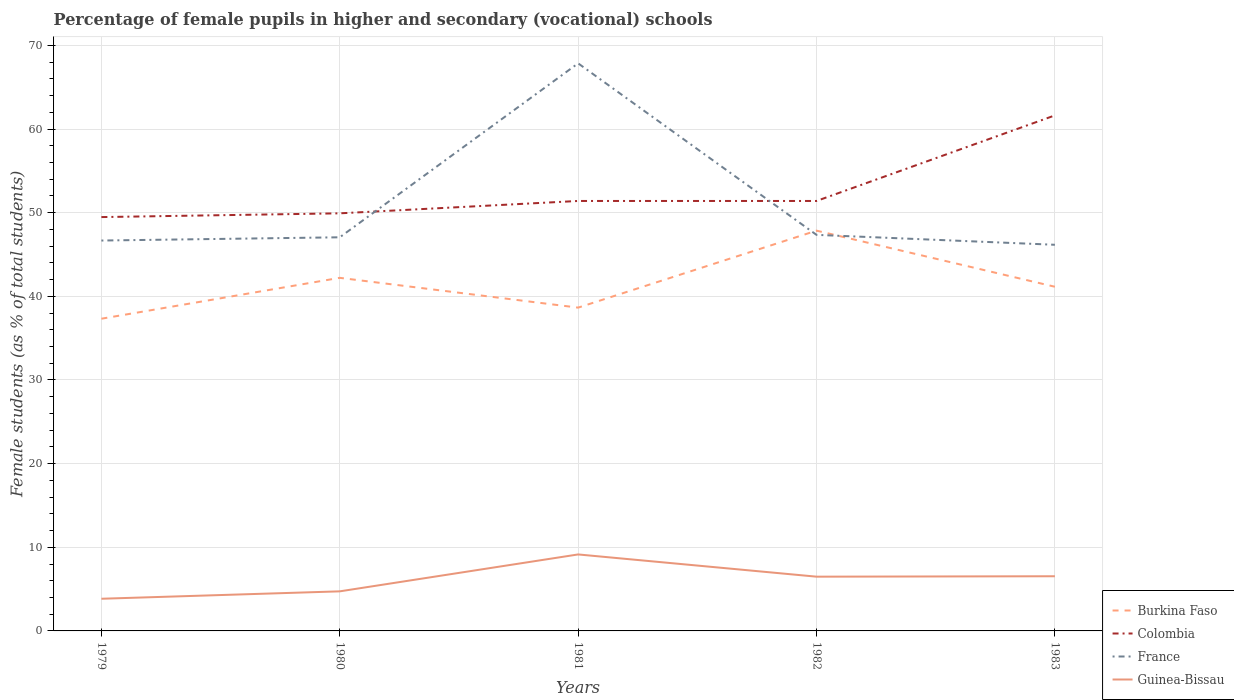Does the line corresponding to France intersect with the line corresponding to Burkina Faso?
Make the answer very short. Yes. Across all years, what is the maximum percentage of female pupils in higher and secondary schools in Guinea-Bissau?
Give a very brief answer. 3.85. In which year was the percentage of female pupils in higher and secondary schools in Colombia maximum?
Your response must be concise. 1979. What is the total percentage of female pupils in higher and secondary schools in Burkina Faso in the graph?
Offer a terse response. -2.5. What is the difference between the highest and the second highest percentage of female pupils in higher and secondary schools in Colombia?
Offer a very short reply. 12.16. What is the difference between the highest and the lowest percentage of female pupils in higher and secondary schools in Colombia?
Your answer should be very brief. 1. Is the percentage of female pupils in higher and secondary schools in Guinea-Bissau strictly greater than the percentage of female pupils in higher and secondary schools in Colombia over the years?
Provide a short and direct response. Yes. How many years are there in the graph?
Provide a succinct answer. 5. What is the difference between two consecutive major ticks on the Y-axis?
Provide a short and direct response. 10. Does the graph contain any zero values?
Provide a succinct answer. No. Does the graph contain grids?
Offer a very short reply. Yes. Where does the legend appear in the graph?
Provide a short and direct response. Bottom right. How many legend labels are there?
Keep it short and to the point. 4. What is the title of the graph?
Offer a very short reply. Percentage of female pupils in higher and secondary (vocational) schools. Does "Cuba" appear as one of the legend labels in the graph?
Offer a terse response. No. What is the label or title of the X-axis?
Ensure brevity in your answer.  Years. What is the label or title of the Y-axis?
Give a very brief answer. Female students (as % of total students). What is the Female students (as % of total students) in Burkina Faso in 1979?
Ensure brevity in your answer.  37.32. What is the Female students (as % of total students) in Colombia in 1979?
Keep it short and to the point. 49.48. What is the Female students (as % of total students) of France in 1979?
Your answer should be very brief. 46.67. What is the Female students (as % of total students) in Guinea-Bissau in 1979?
Make the answer very short. 3.85. What is the Female students (as % of total students) in Burkina Faso in 1980?
Keep it short and to the point. 42.21. What is the Female students (as % of total students) in Colombia in 1980?
Offer a terse response. 49.92. What is the Female students (as % of total students) of France in 1980?
Provide a succinct answer. 47.06. What is the Female students (as % of total students) of Guinea-Bissau in 1980?
Provide a succinct answer. 4.73. What is the Female students (as % of total students) of Burkina Faso in 1981?
Make the answer very short. 38.65. What is the Female students (as % of total students) of Colombia in 1981?
Keep it short and to the point. 51.4. What is the Female students (as % of total students) of France in 1981?
Offer a very short reply. 67.85. What is the Female students (as % of total students) of Guinea-Bissau in 1981?
Provide a succinct answer. 9.14. What is the Female students (as % of total students) in Burkina Faso in 1982?
Your response must be concise. 47.85. What is the Female students (as % of total students) of Colombia in 1982?
Make the answer very short. 51.4. What is the Female students (as % of total students) in France in 1982?
Keep it short and to the point. 47.35. What is the Female students (as % of total students) in Guinea-Bissau in 1982?
Your response must be concise. 6.49. What is the Female students (as % of total students) of Burkina Faso in 1983?
Give a very brief answer. 41.15. What is the Female students (as % of total students) of Colombia in 1983?
Your answer should be compact. 61.63. What is the Female students (as % of total students) of France in 1983?
Offer a terse response. 46.16. What is the Female students (as % of total students) of Guinea-Bissau in 1983?
Give a very brief answer. 6.54. Across all years, what is the maximum Female students (as % of total students) in Burkina Faso?
Ensure brevity in your answer.  47.85. Across all years, what is the maximum Female students (as % of total students) of Colombia?
Offer a very short reply. 61.63. Across all years, what is the maximum Female students (as % of total students) of France?
Your response must be concise. 67.85. Across all years, what is the maximum Female students (as % of total students) in Guinea-Bissau?
Your response must be concise. 9.14. Across all years, what is the minimum Female students (as % of total students) in Burkina Faso?
Provide a succinct answer. 37.32. Across all years, what is the minimum Female students (as % of total students) in Colombia?
Your response must be concise. 49.48. Across all years, what is the minimum Female students (as % of total students) in France?
Your answer should be compact. 46.16. Across all years, what is the minimum Female students (as % of total students) in Guinea-Bissau?
Your response must be concise. 3.85. What is the total Female students (as % of total students) in Burkina Faso in the graph?
Offer a terse response. 207.19. What is the total Female students (as % of total students) in Colombia in the graph?
Provide a succinct answer. 263.83. What is the total Female students (as % of total students) of France in the graph?
Your answer should be compact. 255.1. What is the total Female students (as % of total students) of Guinea-Bissau in the graph?
Ensure brevity in your answer.  30.74. What is the difference between the Female students (as % of total students) of Burkina Faso in 1979 and that in 1980?
Provide a short and direct response. -4.89. What is the difference between the Female students (as % of total students) in Colombia in 1979 and that in 1980?
Make the answer very short. -0.45. What is the difference between the Female students (as % of total students) in France in 1979 and that in 1980?
Keep it short and to the point. -0.39. What is the difference between the Female students (as % of total students) in Guinea-Bissau in 1979 and that in 1980?
Provide a short and direct response. -0.89. What is the difference between the Female students (as % of total students) of Burkina Faso in 1979 and that in 1981?
Make the answer very short. -1.33. What is the difference between the Female students (as % of total students) of Colombia in 1979 and that in 1981?
Offer a very short reply. -1.93. What is the difference between the Female students (as % of total students) in France in 1979 and that in 1981?
Offer a terse response. -21.18. What is the difference between the Female students (as % of total students) of Guinea-Bissau in 1979 and that in 1981?
Provide a short and direct response. -5.3. What is the difference between the Female students (as % of total students) in Burkina Faso in 1979 and that in 1982?
Provide a short and direct response. -10.53. What is the difference between the Female students (as % of total students) in Colombia in 1979 and that in 1982?
Make the answer very short. -1.93. What is the difference between the Female students (as % of total students) of France in 1979 and that in 1982?
Your answer should be compact. -0.68. What is the difference between the Female students (as % of total students) in Guinea-Bissau in 1979 and that in 1982?
Your response must be concise. -2.64. What is the difference between the Female students (as % of total students) in Burkina Faso in 1979 and that in 1983?
Give a very brief answer. -3.82. What is the difference between the Female students (as % of total students) of Colombia in 1979 and that in 1983?
Keep it short and to the point. -12.16. What is the difference between the Female students (as % of total students) in France in 1979 and that in 1983?
Your answer should be compact. 0.51. What is the difference between the Female students (as % of total students) in Guinea-Bissau in 1979 and that in 1983?
Offer a very short reply. -2.69. What is the difference between the Female students (as % of total students) of Burkina Faso in 1980 and that in 1981?
Make the answer very short. 3.56. What is the difference between the Female students (as % of total students) in Colombia in 1980 and that in 1981?
Your answer should be very brief. -1.48. What is the difference between the Female students (as % of total students) in France in 1980 and that in 1981?
Your answer should be very brief. -20.8. What is the difference between the Female students (as % of total students) of Guinea-Bissau in 1980 and that in 1981?
Ensure brevity in your answer.  -4.41. What is the difference between the Female students (as % of total students) in Burkina Faso in 1980 and that in 1982?
Ensure brevity in your answer.  -5.64. What is the difference between the Female students (as % of total students) in Colombia in 1980 and that in 1982?
Give a very brief answer. -1.48. What is the difference between the Female students (as % of total students) in France in 1980 and that in 1982?
Provide a short and direct response. -0.29. What is the difference between the Female students (as % of total students) of Guinea-Bissau in 1980 and that in 1982?
Keep it short and to the point. -1.75. What is the difference between the Female students (as % of total students) in Burkina Faso in 1980 and that in 1983?
Make the answer very short. 1.07. What is the difference between the Female students (as % of total students) in Colombia in 1980 and that in 1983?
Your response must be concise. -11.71. What is the difference between the Female students (as % of total students) of France in 1980 and that in 1983?
Your response must be concise. 0.9. What is the difference between the Female students (as % of total students) of Guinea-Bissau in 1980 and that in 1983?
Your answer should be very brief. -1.8. What is the difference between the Female students (as % of total students) of Burkina Faso in 1981 and that in 1982?
Offer a terse response. -9.2. What is the difference between the Female students (as % of total students) in Colombia in 1981 and that in 1982?
Offer a very short reply. 0. What is the difference between the Female students (as % of total students) of France in 1981 and that in 1982?
Keep it short and to the point. 20.5. What is the difference between the Female students (as % of total students) of Guinea-Bissau in 1981 and that in 1982?
Make the answer very short. 2.66. What is the difference between the Female students (as % of total students) in Burkina Faso in 1981 and that in 1983?
Your answer should be very brief. -2.5. What is the difference between the Female students (as % of total students) in Colombia in 1981 and that in 1983?
Offer a very short reply. -10.23. What is the difference between the Female students (as % of total students) in France in 1981 and that in 1983?
Offer a very short reply. 21.69. What is the difference between the Female students (as % of total students) in Guinea-Bissau in 1981 and that in 1983?
Provide a succinct answer. 2.61. What is the difference between the Female students (as % of total students) in Burkina Faso in 1982 and that in 1983?
Give a very brief answer. 6.71. What is the difference between the Female students (as % of total students) of Colombia in 1982 and that in 1983?
Provide a succinct answer. -10.23. What is the difference between the Female students (as % of total students) in France in 1982 and that in 1983?
Make the answer very short. 1.19. What is the difference between the Female students (as % of total students) of Guinea-Bissau in 1982 and that in 1983?
Offer a very short reply. -0.05. What is the difference between the Female students (as % of total students) in Burkina Faso in 1979 and the Female students (as % of total students) in Colombia in 1980?
Offer a terse response. -12.6. What is the difference between the Female students (as % of total students) in Burkina Faso in 1979 and the Female students (as % of total students) in France in 1980?
Your response must be concise. -9.74. What is the difference between the Female students (as % of total students) of Burkina Faso in 1979 and the Female students (as % of total students) of Guinea-Bissau in 1980?
Your answer should be compact. 32.59. What is the difference between the Female students (as % of total students) of Colombia in 1979 and the Female students (as % of total students) of France in 1980?
Offer a terse response. 2.42. What is the difference between the Female students (as % of total students) in Colombia in 1979 and the Female students (as % of total students) in Guinea-Bissau in 1980?
Provide a succinct answer. 44.74. What is the difference between the Female students (as % of total students) of France in 1979 and the Female students (as % of total students) of Guinea-Bissau in 1980?
Your response must be concise. 41.94. What is the difference between the Female students (as % of total students) of Burkina Faso in 1979 and the Female students (as % of total students) of Colombia in 1981?
Keep it short and to the point. -14.08. What is the difference between the Female students (as % of total students) in Burkina Faso in 1979 and the Female students (as % of total students) in France in 1981?
Offer a very short reply. -30.53. What is the difference between the Female students (as % of total students) of Burkina Faso in 1979 and the Female students (as % of total students) of Guinea-Bissau in 1981?
Keep it short and to the point. 28.18. What is the difference between the Female students (as % of total students) in Colombia in 1979 and the Female students (as % of total students) in France in 1981?
Keep it short and to the point. -18.38. What is the difference between the Female students (as % of total students) of Colombia in 1979 and the Female students (as % of total students) of Guinea-Bissau in 1981?
Ensure brevity in your answer.  40.33. What is the difference between the Female students (as % of total students) of France in 1979 and the Female students (as % of total students) of Guinea-Bissau in 1981?
Make the answer very short. 37.53. What is the difference between the Female students (as % of total students) of Burkina Faso in 1979 and the Female students (as % of total students) of Colombia in 1982?
Provide a succinct answer. -14.08. What is the difference between the Female students (as % of total students) of Burkina Faso in 1979 and the Female students (as % of total students) of France in 1982?
Offer a very short reply. -10.03. What is the difference between the Female students (as % of total students) of Burkina Faso in 1979 and the Female students (as % of total students) of Guinea-Bissau in 1982?
Ensure brevity in your answer.  30.84. What is the difference between the Female students (as % of total students) in Colombia in 1979 and the Female students (as % of total students) in France in 1982?
Provide a short and direct response. 2.13. What is the difference between the Female students (as % of total students) in Colombia in 1979 and the Female students (as % of total students) in Guinea-Bissau in 1982?
Keep it short and to the point. 42.99. What is the difference between the Female students (as % of total students) in France in 1979 and the Female students (as % of total students) in Guinea-Bissau in 1982?
Give a very brief answer. 40.19. What is the difference between the Female students (as % of total students) of Burkina Faso in 1979 and the Female students (as % of total students) of Colombia in 1983?
Your answer should be very brief. -24.31. What is the difference between the Female students (as % of total students) in Burkina Faso in 1979 and the Female students (as % of total students) in France in 1983?
Offer a terse response. -8.84. What is the difference between the Female students (as % of total students) of Burkina Faso in 1979 and the Female students (as % of total students) of Guinea-Bissau in 1983?
Provide a short and direct response. 30.79. What is the difference between the Female students (as % of total students) of Colombia in 1979 and the Female students (as % of total students) of France in 1983?
Keep it short and to the point. 3.31. What is the difference between the Female students (as % of total students) in Colombia in 1979 and the Female students (as % of total students) in Guinea-Bissau in 1983?
Make the answer very short. 42.94. What is the difference between the Female students (as % of total students) of France in 1979 and the Female students (as % of total students) of Guinea-Bissau in 1983?
Your response must be concise. 40.13. What is the difference between the Female students (as % of total students) in Burkina Faso in 1980 and the Female students (as % of total students) in Colombia in 1981?
Make the answer very short. -9.19. What is the difference between the Female students (as % of total students) of Burkina Faso in 1980 and the Female students (as % of total students) of France in 1981?
Your answer should be compact. -25.64. What is the difference between the Female students (as % of total students) in Burkina Faso in 1980 and the Female students (as % of total students) in Guinea-Bissau in 1981?
Your answer should be very brief. 33.07. What is the difference between the Female students (as % of total students) in Colombia in 1980 and the Female students (as % of total students) in France in 1981?
Offer a very short reply. -17.93. What is the difference between the Female students (as % of total students) in Colombia in 1980 and the Female students (as % of total students) in Guinea-Bissau in 1981?
Your response must be concise. 40.78. What is the difference between the Female students (as % of total students) in France in 1980 and the Female students (as % of total students) in Guinea-Bissau in 1981?
Give a very brief answer. 37.92. What is the difference between the Female students (as % of total students) of Burkina Faso in 1980 and the Female students (as % of total students) of Colombia in 1982?
Offer a very short reply. -9.19. What is the difference between the Female students (as % of total students) in Burkina Faso in 1980 and the Female students (as % of total students) in France in 1982?
Offer a very short reply. -5.14. What is the difference between the Female students (as % of total students) of Burkina Faso in 1980 and the Female students (as % of total students) of Guinea-Bissau in 1982?
Offer a terse response. 35.73. What is the difference between the Female students (as % of total students) of Colombia in 1980 and the Female students (as % of total students) of France in 1982?
Make the answer very short. 2.57. What is the difference between the Female students (as % of total students) of Colombia in 1980 and the Female students (as % of total students) of Guinea-Bissau in 1982?
Keep it short and to the point. 43.44. What is the difference between the Female students (as % of total students) of France in 1980 and the Female students (as % of total students) of Guinea-Bissau in 1982?
Give a very brief answer. 40.57. What is the difference between the Female students (as % of total students) in Burkina Faso in 1980 and the Female students (as % of total students) in Colombia in 1983?
Give a very brief answer. -19.42. What is the difference between the Female students (as % of total students) in Burkina Faso in 1980 and the Female students (as % of total students) in France in 1983?
Your response must be concise. -3.95. What is the difference between the Female students (as % of total students) in Burkina Faso in 1980 and the Female students (as % of total students) in Guinea-Bissau in 1983?
Your answer should be compact. 35.68. What is the difference between the Female students (as % of total students) of Colombia in 1980 and the Female students (as % of total students) of France in 1983?
Give a very brief answer. 3.76. What is the difference between the Female students (as % of total students) of Colombia in 1980 and the Female students (as % of total students) of Guinea-Bissau in 1983?
Your response must be concise. 43.39. What is the difference between the Female students (as % of total students) in France in 1980 and the Female students (as % of total students) in Guinea-Bissau in 1983?
Give a very brief answer. 40.52. What is the difference between the Female students (as % of total students) of Burkina Faso in 1981 and the Female students (as % of total students) of Colombia in 1982?
Your answer should be very brief. -12.75. What is the difference between the Female students (as % of total students) in Burkina Faso in 1981 and the Female students (as % of total students) in France in 1982?
Ensure brevity in your answer.  -8.7. What is the difference between the Female students (as % of total students) of Burkina Faso in 1981 and the Female students (as % of total students) of Guinea-Bissau in 1982?
Your response must be concise. 32.16. What is the difference between the Female students (as % of total students) in Colombia in 1981 and the Female students (as % of total students) in France in 1982?
Make the answer very short. 4.05. What is the difference between the Female students (as % of total students) of Colombia in 1981 and the Female students (as % of total students) of Guinea-Bissau in 1982?
Provide a short and direct response. 44.92. What is the difference between the Female students (as % of total students) of France in 1981 and the Female students (as % of total students) of Guinea-Bissau in 1982?
Offer a terse response. 61.37. What is the difference between the Female students (as % of total students) in Burkina Faso in 1981 and the Female students (as % of total students) in Colombia in 1983?
Provide a succinct answer. -22.98. What is the difference between the Female students (as % of total students) in Burkina Faso in 1981 and the Female students (as % of total students) in France in 1983?
Provide a succinct answer. -7.51. What is the difference between the Female students (as % of total students) in Burkina Faso in 1981 and the Female students (as % of total students) in Guinea-Bissau in 1983?
Your answer should be compact. 32.11. What is the difference between the Female students (as % of total students) of Colombia in 1981 and the Female students (as % of total students) of France in 1983?
Provide a short and direct response. 5.24. What is the difference between the Female students (as % of total students) of Colombia in 1981 and the Female students (as % of total students) of Guinea-Bissau in 1983?
Your answer should be compact. 44.87. What is the difference between the Female students (as % of total students) of France in 1981 and the Female students (as % of total students) of Guinea-Bissau in 1983?
Offer a terse response. 61.32. What is the difference between the Female students (as % of total students) in Burkina Faso in 1982 and the Female students (as % of total students) in Colombia in 1983?
Offer a terse response. -13.78. What is the difference between the Female students (as % of total students) in Burkina Faso in 1982 and the Female students (as % of total students) in France in 1983?
Your response must be concise. 1.69. What is the difference between the Female students (as % of total students) of Burkina Faso in 1982 and the Female students (as % of total students) of Guinea-Bissau in 1983?
Make the answer very short. 41.32. What is the difference between the Female students (as % of total students) in Colombia in 1982 and the Female students (as % of total students) in France in 1983?
Offer a very short reply. 5.24. What is the difference between the Female students (as % of total students) of Colombia in 1982 and the Female students (as % of total students) of Guinea-Bissau in 1983?
Provide a short and direct response. 44.86. What is the difference between the Female students (as % of total students) of France in 1982 and the Female students (as % of total students) of Guinea-Bissau in 1983?
Offer a terse response. 40.81. What is the average Female students (as % of total students) in Burkina Faso per year?
Provide a short and direct response. 41.44. What is the average Female students (as % of total students) of Colombia per year?
Your response must be concise. 52.77. What is the average Female students (as % of total students) in France per year?
Your answer should be compact. 51.02. What is the average Female students (as % of total students) of Guinea-Bissau per year?
Offer a very short reply. 6.15. In the year 1979, what is the difference between the Female students (as % of total students) of Burkina Faso and Female students (as % of total students) of Colombia?
Ensure brevity in your answer.  -12.15. In the year 1979, what is the difference between the Female students (as % of total students) in Burkina Faso and Female students (as % of total students) in France?
Provide a succinct answer. -9.35. In the year 1979, what is the difference between the Female students (as % of total students) in Burkina Faso and Female students (as % of total students) in Guinea-Bissau?
Offer a terse response. 33.48. In the year 1979, what is the difference between the Female students (as % of total students) in Colombia and Female students (as % of total students) in France?
Provide a succinct answer. 2.8. In the year 1979, what is the difference between the Female students (as % of total students) in Colombia and Female students (as % of total students) in Guinea-Bissau?
Provide a succinct answer. 45.63. In the year 1979, what is the difference between the Female students (as % of total students) in France and Female students (as % of total students) in Guinea-Bissau?
Offer a terse response. 42.82. In the year 1980, what is the difference between the Female students (as % of total students) in Burkina Faso and Female students (as % of total students) in Colombia?
Keep it short and to the point. -7.71. In the year 1980, what is the difference between the Female students (as % of total students) in Burkina Faso and Female students (as % of total students) in France?
Your answer should be compact. -4.85. In the year 1980, what is the difference between the Female students (as % of total students) in Burkina Faso and Female students (as % of total students) in Guinea-Bissau?
Offer a very short reply. 37.48. In the year 1980, what is the difference between the Female students (as % of total students) of Colombia and Female students (as % of total students) of France?
Provide a short and direct response. 2.86. In the year 1980, what is the difference between the Female students (as % of total students) of Colombia and Female students (as % of total students) of Guinea-Bissau?
Provide a short and direct response. 45.19. In the year 1980, what is the difference between the Female students (as % of total students) of France and Female students (as % of total students) of Guinea-Bissau?
Your response must be concise. 42.33. In the year 1981, what is the difference between the Female students (as % of total students) of Burkina Faso and Female students (as % of total students) of Colombia?
Offer a terse response. -12.75. In the year 1981, what is the difference between the Female students (as % of total students) in Burkina Faso and Female students (as % of total students) in France?
Your answer should be very brief. -29.2. In the year 1981, what is the difference between the Female students (as % of total students) in Burkina Faso and Female students (as % of total students) in Guinea-Bissau?
Make the answer very short. 29.51. In the year 1981, what is the difference between the Female students (as % of total students) in Colombia and Female students (as % of total students) in France?
Your answer should be very brief. -16.45. In the year 1981, what is the difference between the Female students (as % of total students) of Colombia and Female students (as % of total students) of Guinea-Bissau?
Your answer should be compact. 42.26. In the year 1981, what is the difference between the Female students (as % of total students) in France and Female students (as % of total students) in Guinea-Bissau?
Provide a succinct answer. 58.71. In the year 1982, what is the difference between the Female students (as % of total students) of Burkina Faso and Female students (as % of total students) of Colombia?
Make the answer very short. -3.55. In the year 1982, what is the difference between the Female students (as % of total students) in Burkina Faso and Female students (as % of total students) in France?
Offer a terse response. 0.5. In the year 1982, what is the difference between the Female students (as % of total students) of Burkina Faso and Female students (as % of total students) of Guinea-Bissau?
Keep it short and to the point. 41.37. In the year 1982, what is the difference between the Female students (as % of total students) of Colombia and Female students (as % of total students) of France?
Provide a succinct answer. 4.05. In the year 1982, what is the difference between the Female students (as % of total students) in Colombia and Female students (as % of total students) in Guinea-Bissau?
Offer a very short reply. 44.91. In the year 1982, what is the difference between the Female students (as % of total students) of France and Female students (as % of total students) of Guinea-Bissau?
Your answer should be compact. 40.86. In the year 1983, what is the difference between the Female students (as % of total students) of Burkina Faso and Female students (as % of total students) of Colombia?
Offer a terse response. -20.48. In the year 1983, what is the difference between the Female students (as % of total students) of Burkina Faso and Female students (as % of total students) of France?
Ensure brevity in your answer.  -5.02. In the year 1983, what is the difference between the Female students (as % of total students) of Burkina Faso and Female students (as % of total students) of Guinea-Bissau?
Offer a terse response. 34.61. In the year 1983, what is the difference between the Female students (as % of total students) of Colombia and Female students (as % of total students) of France?
Your response must be concise. 15.47. In the year 1983, what is the difference between the Female students (as % of total students) in Colombia and Female students (as % of total students) in Guinea-Bissau?
Your answer should be compact. 55.1. In the year 1983, what is the difference between the Female students (as % of total students) in France and Female students (as % of total students) in Guinea-Bissau?
Your answer should be very brief. 39.63. What is the ratio of the Female students (as % of total students) of Burkina Faso in 1979 to that in 1980?
Your answer should be very brief. 0.88. What is the ratio of the Female students (as % of total students) of Colombia in 1979 to that in 1980?
Your answer should be compact. 0.99. What is the ratio of the Female students (as % of total students) in Guinea-Bissau in 1979 to that in 1980?
Make the answer very short. 0.81. What is the ratio of the Female students (as % of total students) of Burkina Faso in 1979 to that in 1981?
Offer a very short reply. 0.97. What is the ratio of the Female students (as % of total students) in Colombia in 1979 to that in 1981?
Give a very brief answer. 0.96. What is the ratio of the Female students (as % of total students) in France in 1979 to that in 1981?
Provide a short and direct response. 0.69. What is the ratio of the Female students (as % of total students) of Guinea-Bissau in 1979 to that in 1981?
Give a very brief answer. 0.42. What is the ratio of the Female students (as % of total students) in Burkina Faso in 1979 to that in 1982?
Provide a short and direct response. 0.78. What is the ratio of the Female students (as % of total students) of Colombia in 1979 to that in 1982?
Give a very brief answer. 0.96. What is the ratio of the Female students (as % of total students) in France in 1979 to that in 1982?
Offer a terse response. 0.99. What is the ratio of the Female students (as % of total students) of Guinea-Bissau in 1979 to that in 1982?
Offer a very short reply. 0.59. What is the ratio of the Female students (as % of total students) of Burkina Faso in 1979 to that in 1983?
Offer a very short reply. 0.91. What is the ratio of the Female students (as % of total students) of Colombia in 1979 to that in 1983?
Provide a succinct answer. 0.8. What is the ratio of the Female students (as % of total students) of France in 1979 to that in 1983?
Offer a very short reply. 1.01. What is the ratio of the Female students (as % of total students) in Guinea-Bissau in 1979 to that in 1983?
Your answer should be very brief. 0.59. What is the ratio of the Female students (as % of total students) of Burkina Faso in 1980 to that in 1981?
Keep it short and to the point. 1.09. What is the ratio of the Female students (as % of total students) in Colombia in 1980 to that in 1981?
Provide a succinct answer. 0.97. What is the ratio of the Female students (as % of total students) in France in 1980 to that in 1981?
Offer a terse response. 0.69. What is the ratio of the Female students (as % of total students) in Guinea-Bissau in 1980 to that in 1981?
Your answer should be compact. 0.52. What is the ratio of the Female students (as % of total students) in Burkina Faso in 1980 to that in 1982?
Your answer should be very brief. 0.88. What is the ratio of the Female students (as % of total students) in Colombia in 1980 to that in 1982?
Give a very brief answer. 0.97. What is the ratio of the Female students (as % of total students) of Guinea-Bissau in 1980 to that in 1982?
Your response must be concise. 0.73. What is the ratio of the Female students (as % of total students) of Burkina Faso in 1980 to that in 1983?
Provide a succinct answer. 1.03. What is the ratio of the Female students (as % of total students) in Colombia in 1980 to that in 1983?
Ensure brevity in your answer.  0.81. What is the ratio of the Female students (as % of total students) of France in 1980 to that in 1983?
Keep it short and to the point. 1.02. What is the ratio of the Female students (as % of total students) of Guinea-Bissau in 1980 to that in 1983?
Your answer should be compact. 0.72. What is the ratio of the Female students (as % of total students) in Burkina Faso in 1981 to that in 1982?
Your answer should be compact. 0.81. What is the ratio of the Female students (as % of total students) of France in 1981 to that in 1982?
Your answer should be very brief. 1.43. What is the ratio of the Female students (as % of total students) of Guinea-Bissau in 1981 to that in 1982?
Give a very brief answer. 1.41. What is the ratio of the Female students (as % of total students) in Burkina Faso in 1981 to that in 1983?
Provide a succinct answer. 0.94. What is the ratio of the Female students (as % of total students) in Colombia in 1981 to that in 1983?
Give a very brief answer. 0.83. What is the ratio of the Female students (as % of total students) of France in 1981 to that in 1983?
Ensure brevity in your answer.  1.47. What is the ratio of the Female students (as % of total students) of Guinea-Bissau in 1981 to that in 1983?
Keep it short and to the point. 1.4. What is the ratio of the Female students (as % of total students) in Burkina Faso in 1982 to that in 1983?
Make the answer very short. 1.16. What is the ratio of the Female students (as % of total students) of Colombia in 1982 to that in 1983?
Make the answer very short. 0.83. What is the ratio of the Female students (as % of total students) in France in 1982 to that in 1983?
Provide a short and direct response. 1.03. What is the difference between the highest and the second highest Female students (as % of total students) of Burkina Faso?
Your response must be concise. 5.64. What is the difference between the highest and the second highest Female students (as % of total students) in Colombia?
Provide a succinct answer. 10.23. What is the difference between the highest and the second highest Female students (as % of total students) of France?
Your answer should be compact. 20.5. What is the difference between the highest and the second highest Female students (as % of total students) in Guinea-Bissau?
Your answer should be compact. 2.61. What is the difference between the highest and the lowest Female students (as % of total students) of Burkina Faso?
Provide a succinct answer. 10.53. What is the difference between the highest and the lowest Female students (as % of total students) of Colombia?
Give a very brief answer. 12.16. What is the difference between the highest and the lowest Female students (as % of total students) in France?
Provide a succinct answer. 21.69. What is the difference between the highest and the lowest Female students (as % of total students) in Guinea-Bissau?
Ensure brevity in your answer.  5.3. 